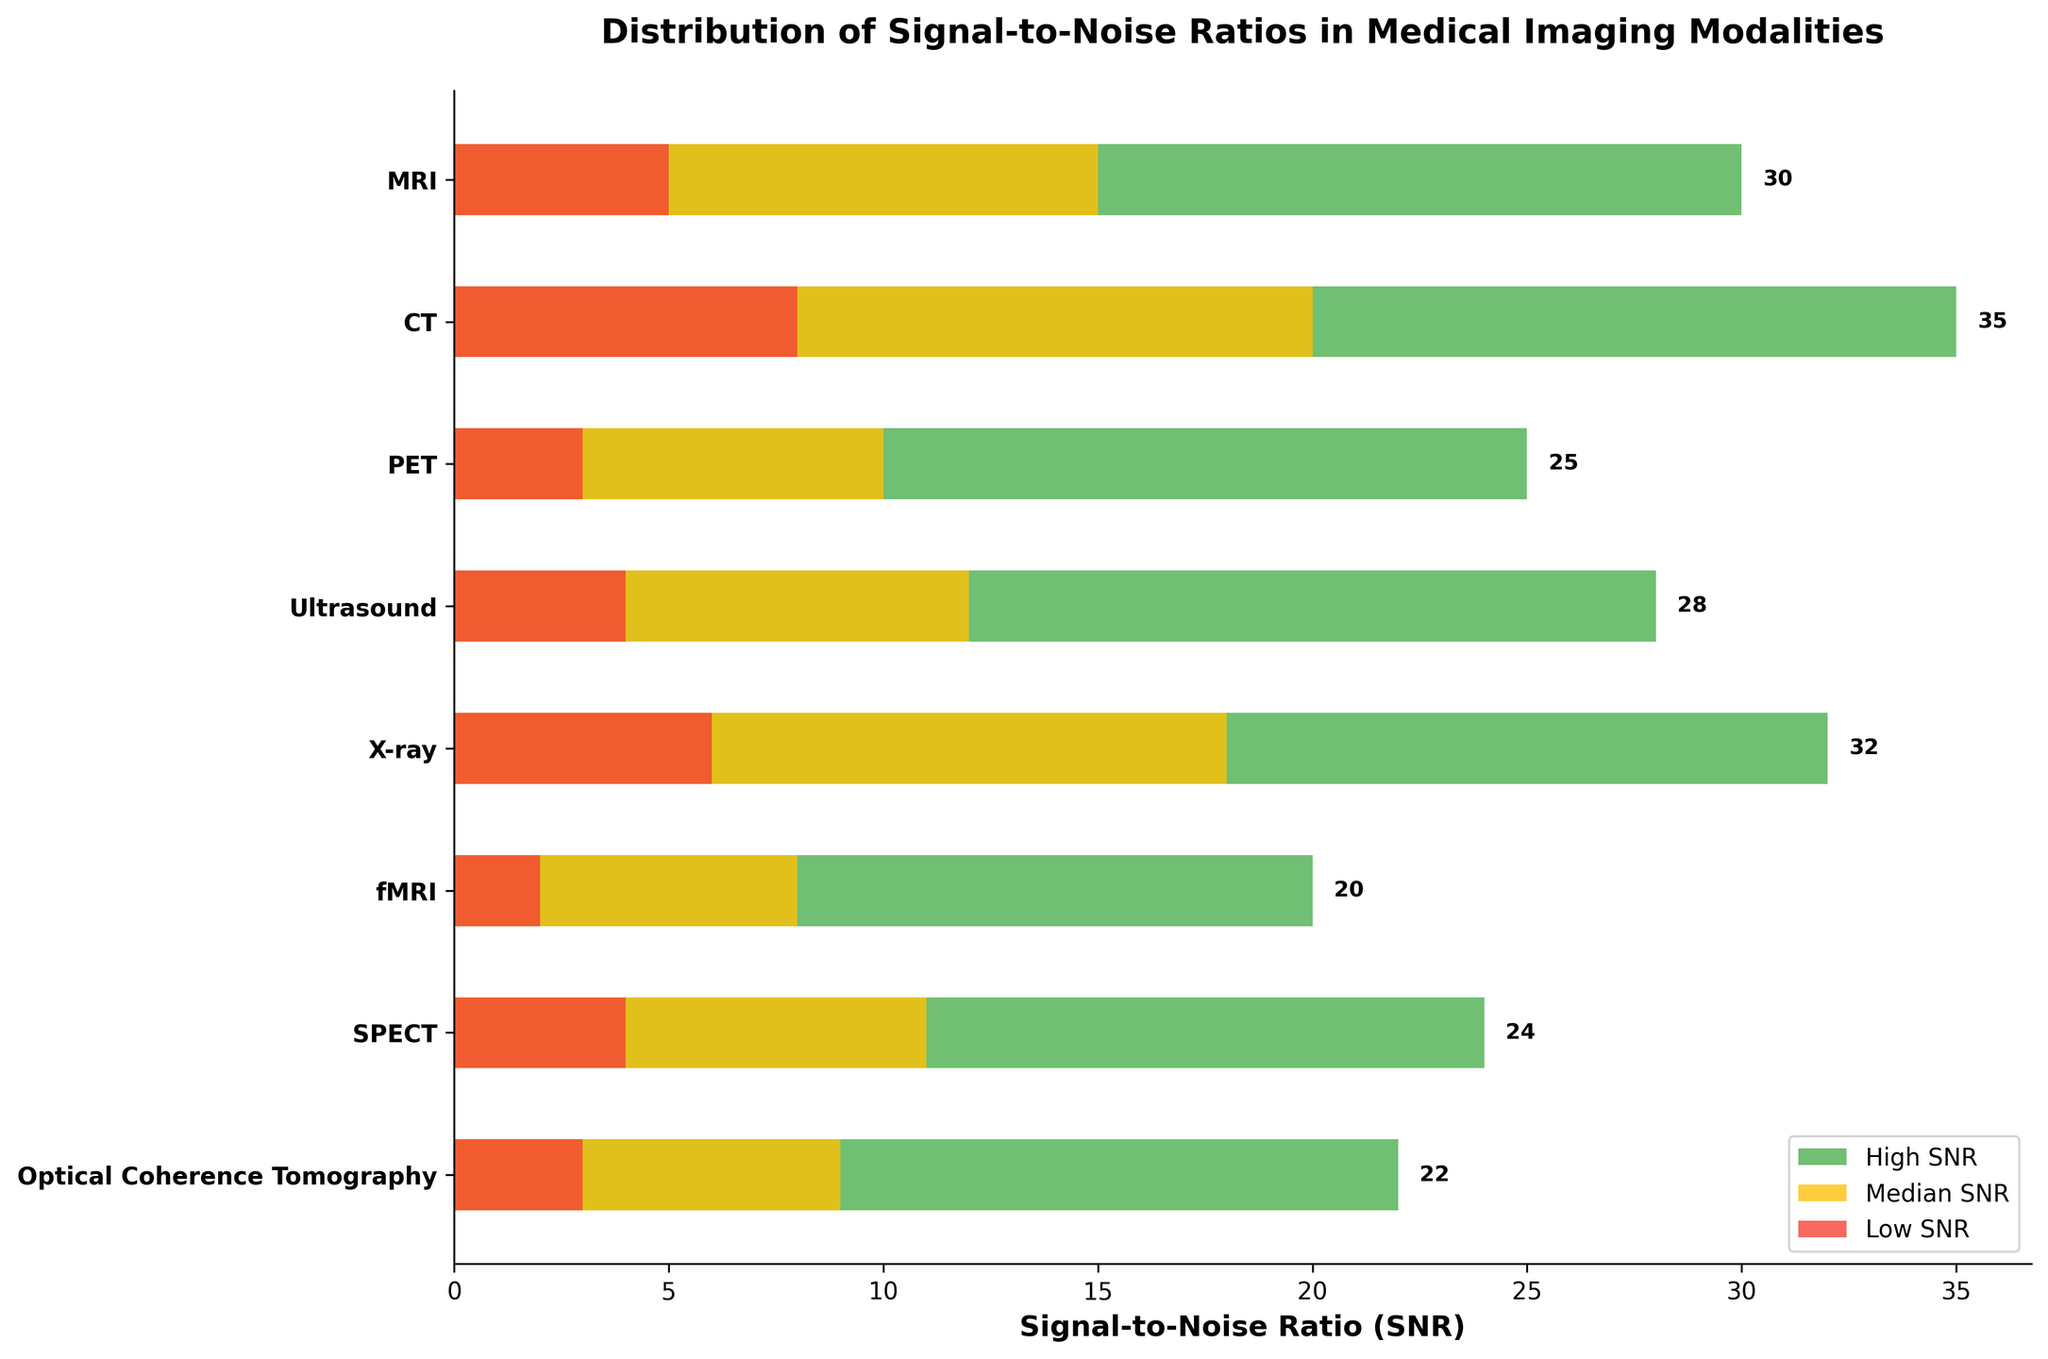which medical imaging modality has the highest high SNR? To answer this, observe the green bars representing the high SNR values. Compare the lengths of all the green bars to find the longest. The CT modality has the longest green bar at a value of 35.
Answer: CT Which modality has the lowest median SNR? Look at the yellow bars representing the median SNR values. Compare their lengths to find the shortest bar. The fMRI modality has the shortest yellow bar with a median SNR of 8.
Answer: fMRI What is the total high SNR value when combining PET and Ultrasound? Find the high SNR values for PET (25) and Ultrasound (28). Then, add these values together: 25 + 28 = 53.
Answer: 53 Among MRI and X-ray, which has a higher low SNR? Compare the red bars representing the low SNR values for MRI and X-ray. MRI has a low SNR of 5, while X-ray has a low SNR of 6. Thus, X-ray has a higher low SNR.
Answer: X-ray What is the difference between the high SNR of Optical Coherence Tomography and fMRI? Look at the green bars for Optical Coherence Tomography (22) and fMRI (20). Subtract the fMRI high SNR from the high SNR of Optical Coherence Tomography: 22 - 20 = 2.
Answer: 2 Which modality shows the greatest range (difference between high SNR and low SNR)? Calculate the range for each modality by subtracting the low SNR from the high SNR. Compare these ranges to find the greatest. CT has a range of 35 - 8 = 27, which is the greatest.
Answer: CT How many modalities have a median SNR greater than 15? Check the yellow bars representing median SNR values and count the modalities with values greater than 15. MRI, CT, and X-ray have median SNR values of 15, 20, and 18, respectively, making three modalities.
Answer: 3 Which modality has a high SNR value exactly equal to 24? Observe the green bars and find the bar with a value of 24. The modality with this value is SPECT.
Answer: SPECT What is the average median SNR across all modalities? Sum up the median SNR values: 15 (MRI) + 20 (CT) + 10 (PET) + 12 (Ultrasound) + 18 (X-ray) + 8 (fMRI) + 11 (SPECT) + 9 (Optical Coherence Tomography) = 103. Then, divide by the number of modalities, which is 8: 103 / 8 = 12.875.
Answer: 12.875 